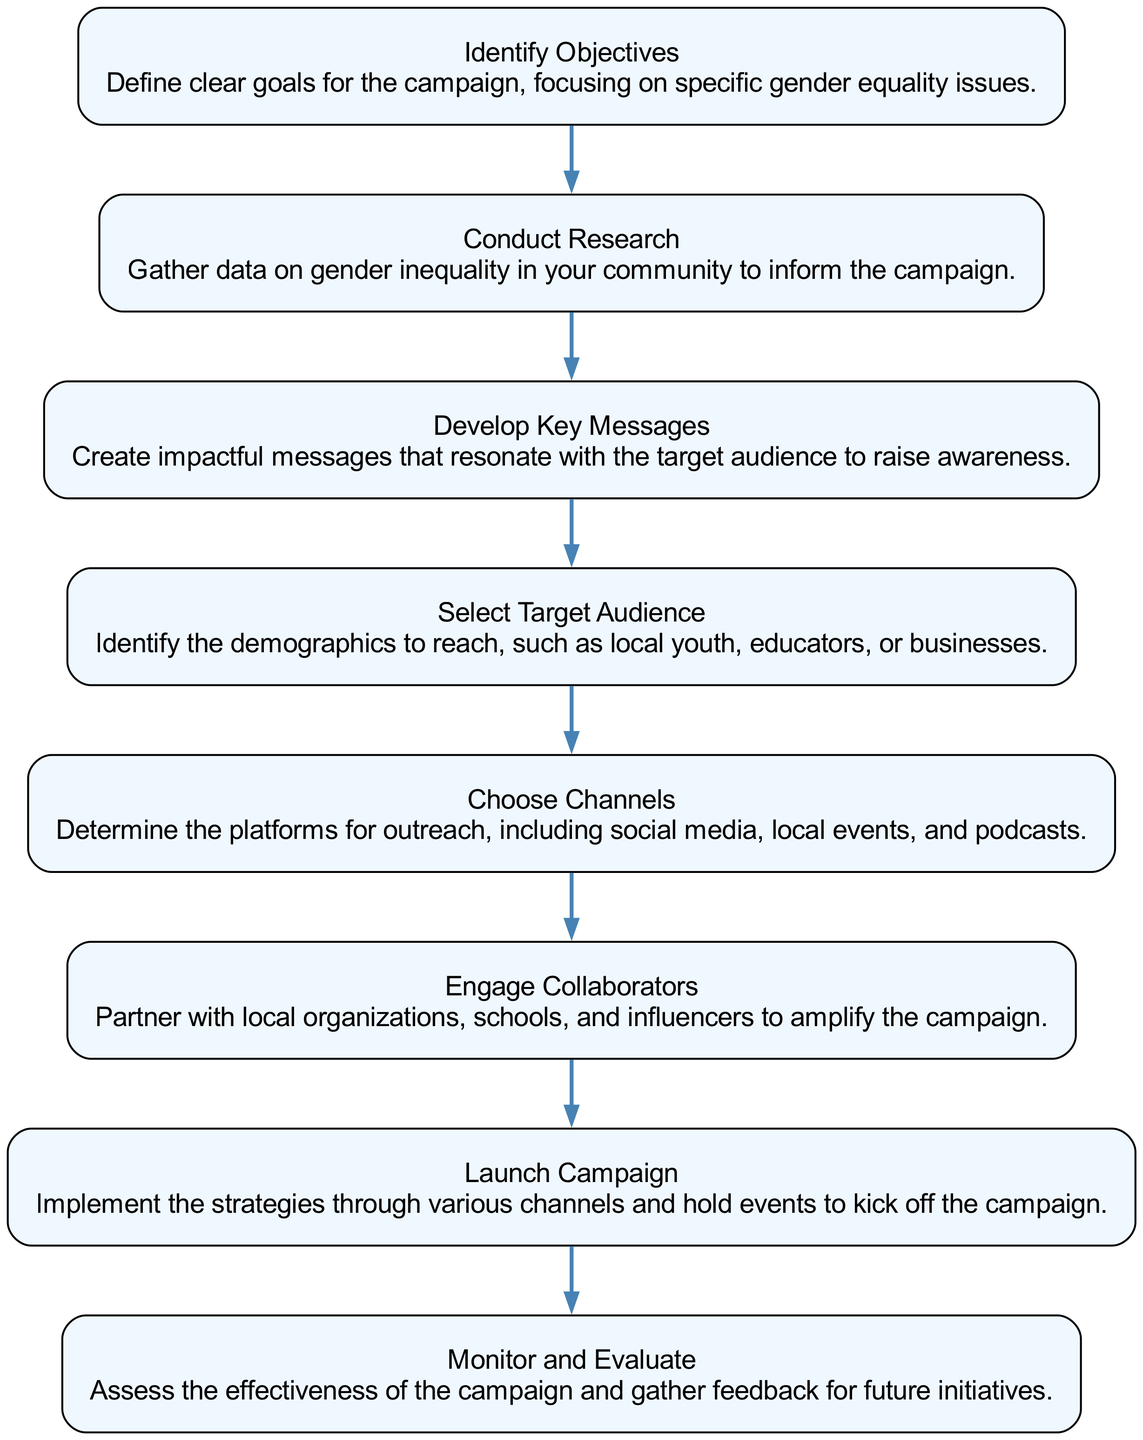What is the first stage of the campaign? The first stage in the flow chart is labeled "Identify Objectives." This is where the campaign's goals are defined, focusing on specific gender equality issues.
Answer: Identify Objectives How many stages are there in total? The diagram lists eight distinct stages. By counting each labeled stage from the beginning to the end of the flow chart, we arrive at a total of eight.
Answer: 8 What does the stage "Monitor and Evaluate" entail? This stage focuses on assessing the effectiveness of the campaign and gathering feedback for future initiatives. This description is specifically provided under that stage in the diagram.
Answer: Assess effectiveness and gather feedback Which stage comes directly after "Develop Key Messages"? After "Develop Key Messages," the next stage indicated in the flow is "Select Target Audience." This follows sequentially in the flow from one to the next.
Answer: Select Target Audience Which two stages involve outside engagement? The stages "Engage Collaborators" and "Launch Campaign" both involve outreach and working with external entities. "Engage Collaborators" emphasizes partnering with organizations, while "Launch Campaign" entails implementing outreach strategies.
Answer: Engage Collaborators and Launch Campaign At what stage is research conducted? Research is conducted in the stage labeled "Conduct Research." This is explicitly stated in the diagram as the stage where data on gender inequality is gathered to inform the campaign.
Answer: Conduct Research What is the final stage of the campaign? The final stage is "Monitor and Evaluate," which concludes the list of stages shown in the flow chart. This is the last stage where the campaign's success is assessed.
Answer: Monitor and Evaluate Which stage involves message crafting? The stage responsible for crafting messages is "Develop Key Messages." This is where impactful messages are created to resonate with the target audience, as described under that stage.
Answer: Develop Key Messages 